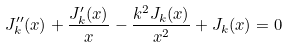Convert formula to latex. <formula><loc_0><loc_0><loc_500><loc_500>J _ { k } ^ { \prime \prime } ( x ) + \frac { J _ { k } ^ { \prime } ( x ) } { x } - \frac { k ^ { 2 } J _ { k } ( x ) } { x ^ { 2 } } + J _ { k } ( x ) = 0</formula> 